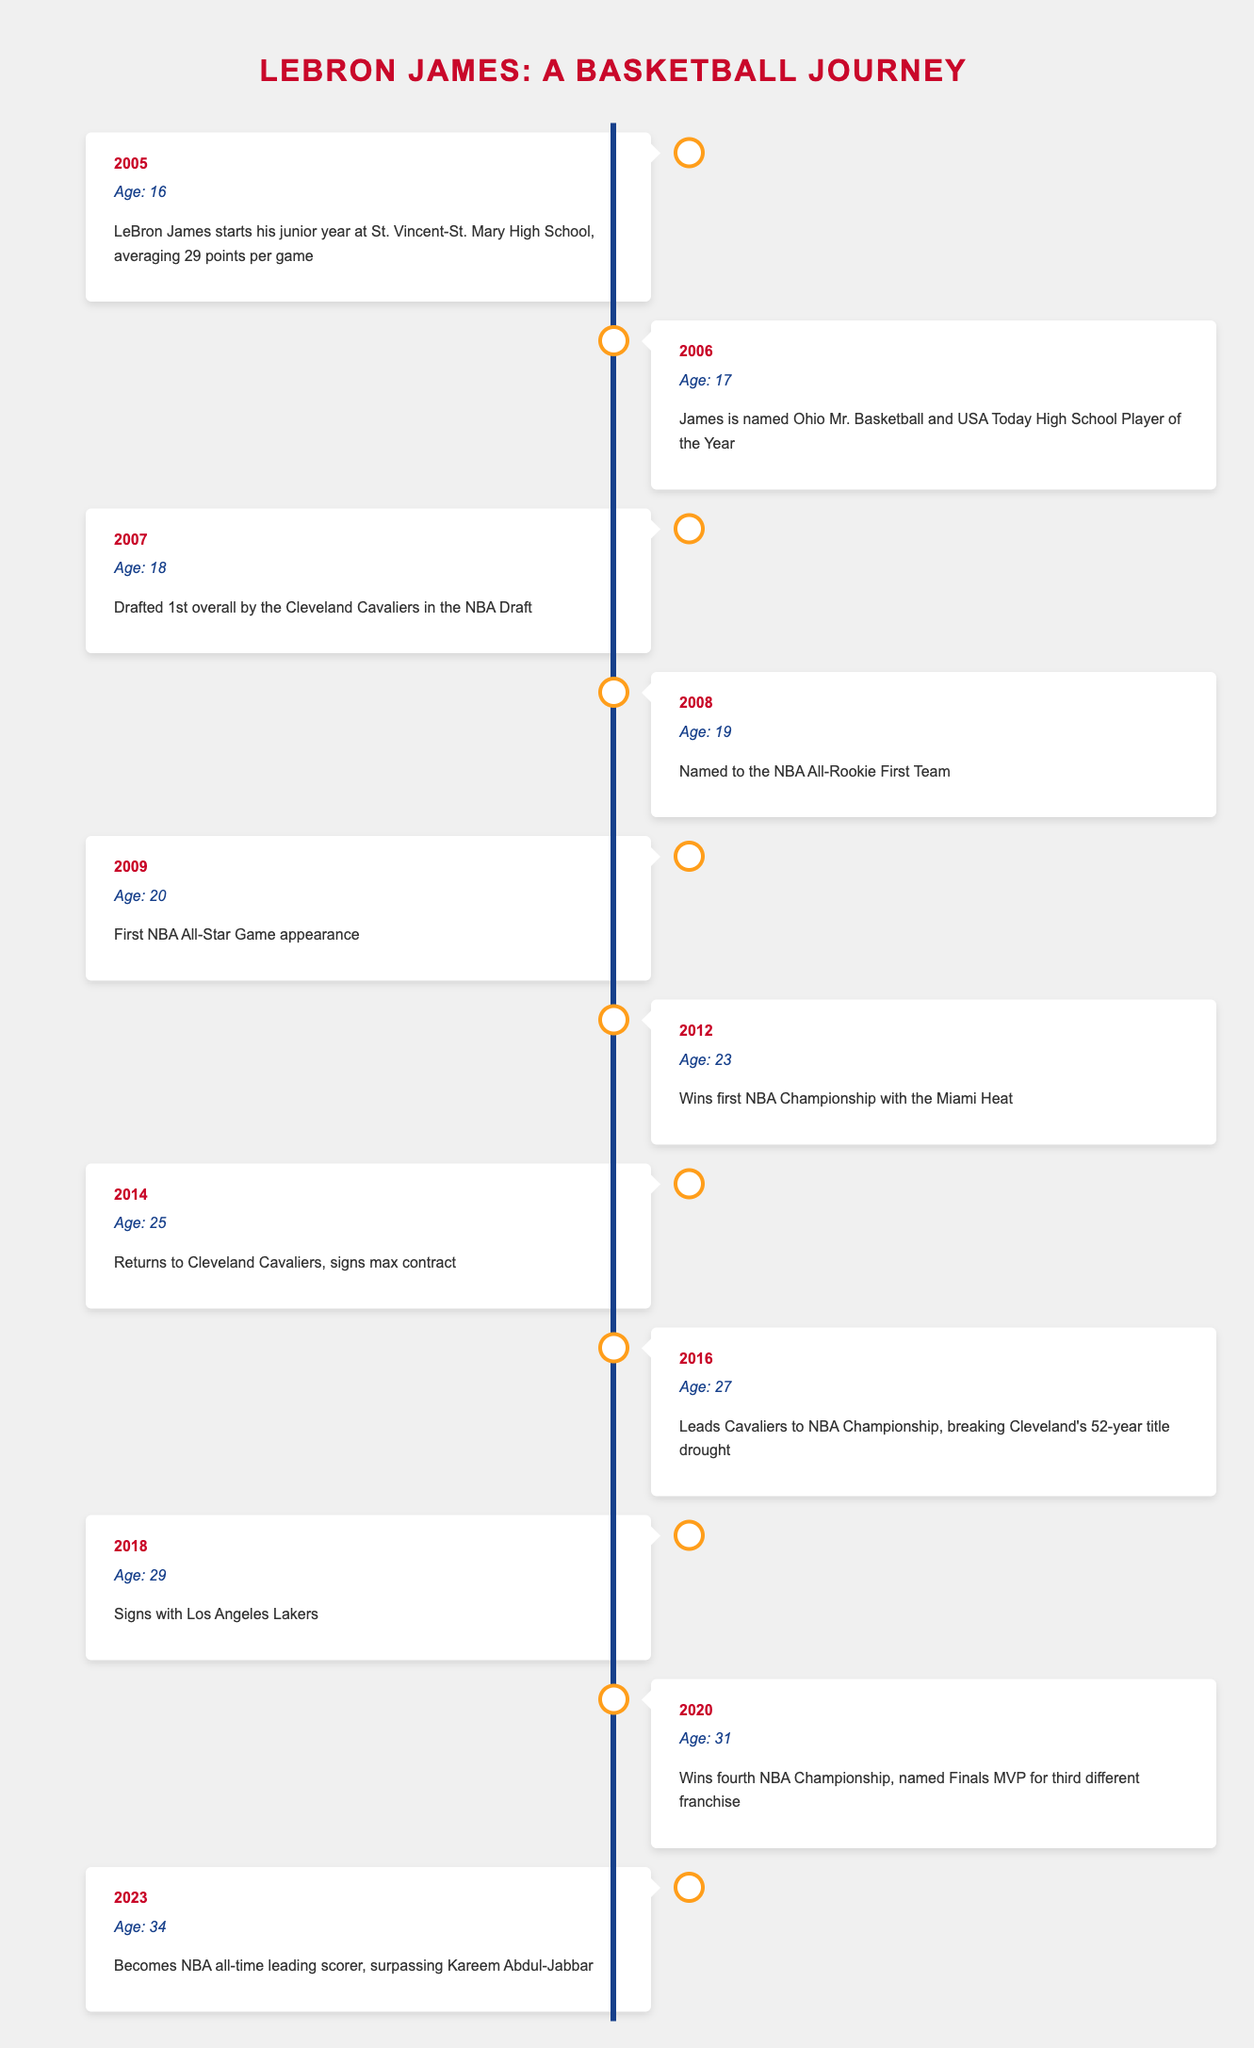What year did LeBron James start his junior year? According to the table, LeBron James started his junior year at St. Vincent-St. Mary High School in 2005.
Answer: 2005 At what age was LeBron drafted into the NBA? The table indicates that LeBron was drafted 1st overall by the Cleveland Cavaliers in 2007 when he was 18 years old.
Answer: 18 How many NBA Championships did LeBron win by 2020? The table shows that LeBron won his first NBA Championship in 2012 and his fourth in 2020. Therefore, by 2020 he had won 4 championships.
Answer: 4 Did LeBron James ever play for the Miami Heat? The table states that LeBron won his first NBA Championship with the Miami Heat in 2012, confirming that he did play for them.
Answer: Yes What was LeBron's age when he became the NBA all-time leading scorer? According to the table, LeBron became the NBA all-time leading scorer in 2023 when he was 34 years old.
Answer: 34 How many years passed between LeBron's first NBA All-Star Game appearance and his fourth NBA Championship victory? From the table, LeBron made his first NBA All-Star Game appearance in 2009 and won his fourth NBA Championship in 2020. The difference in years is 2020 - 2009 = 11 years.
Answer: 11 years Which franchise did LeBron sign with in 2018? The table states that in 2018, LeBron signed with the Los Angeles Lakers.
Answer: Los Angeles Lakers What significant event occurred in LeBron's career in 2016? The table indicates that in 2016, LeBron led the Cavaliers to an NBA Championship, breaking Cleveland's 52-year title drought.
Answer: NBA Championship win in 2016 How many different franchises has LeBron won an NBA Championship with by 2020? By 2020, the table shows he has won championships with three different franchises: Miami Heat, Cleveland Cavaliers, and Los Angeles Lakers.
Answer: 3 